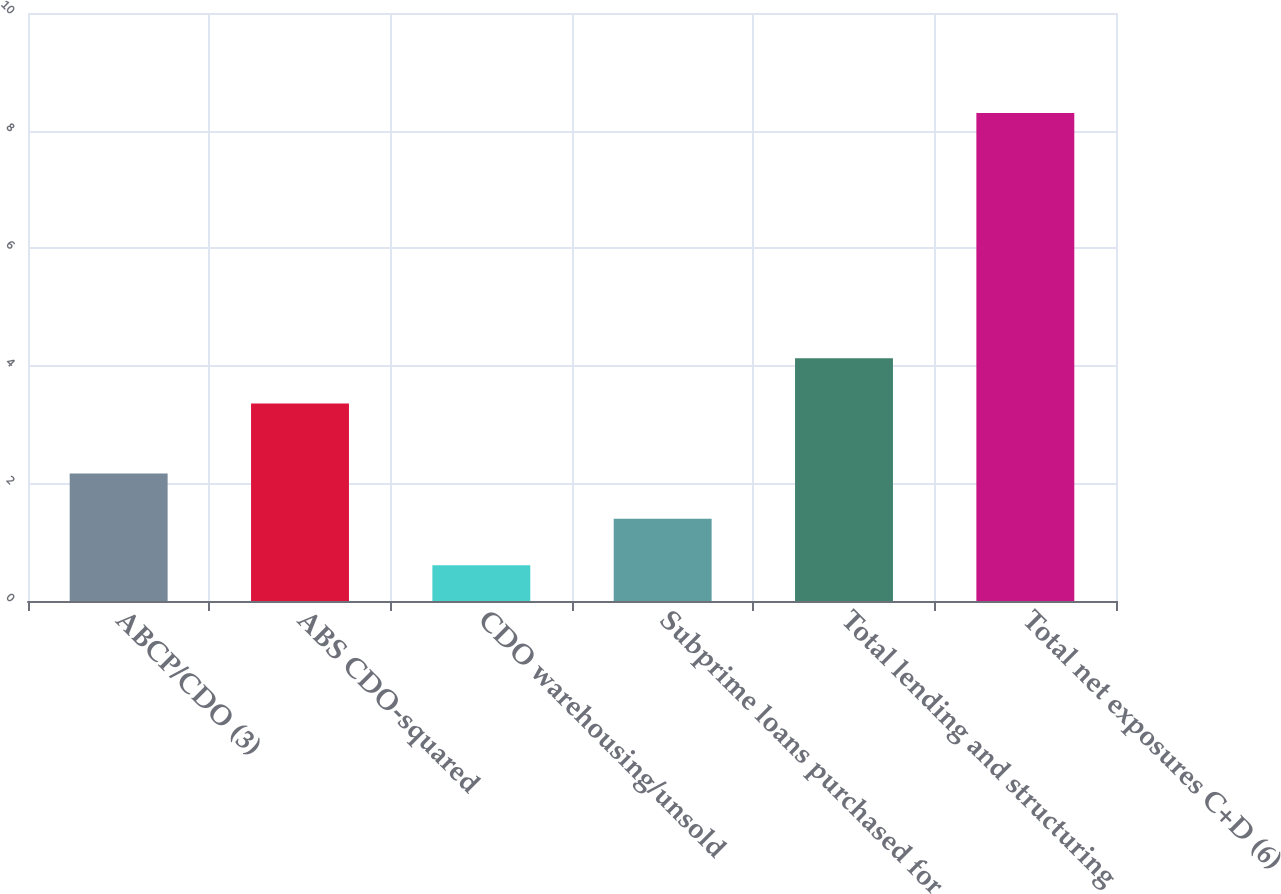<chart> <loc_0><loc_0><loc_500><loc_500><bar_chart><fcel>ABCP/CDO (3)<fcel>ABS CDO-squared<fcel>CDO warehousing/unsold<fcel>Subprime loans purchased for<fcel>Total lending and structuring<fcel>Total net exposures C+D (6)<nl><fcel>2.17<fcel>3.36<fcel>0.61<fcel>1.4<fcel>4.13<fcel>8.3<nl></chart> 